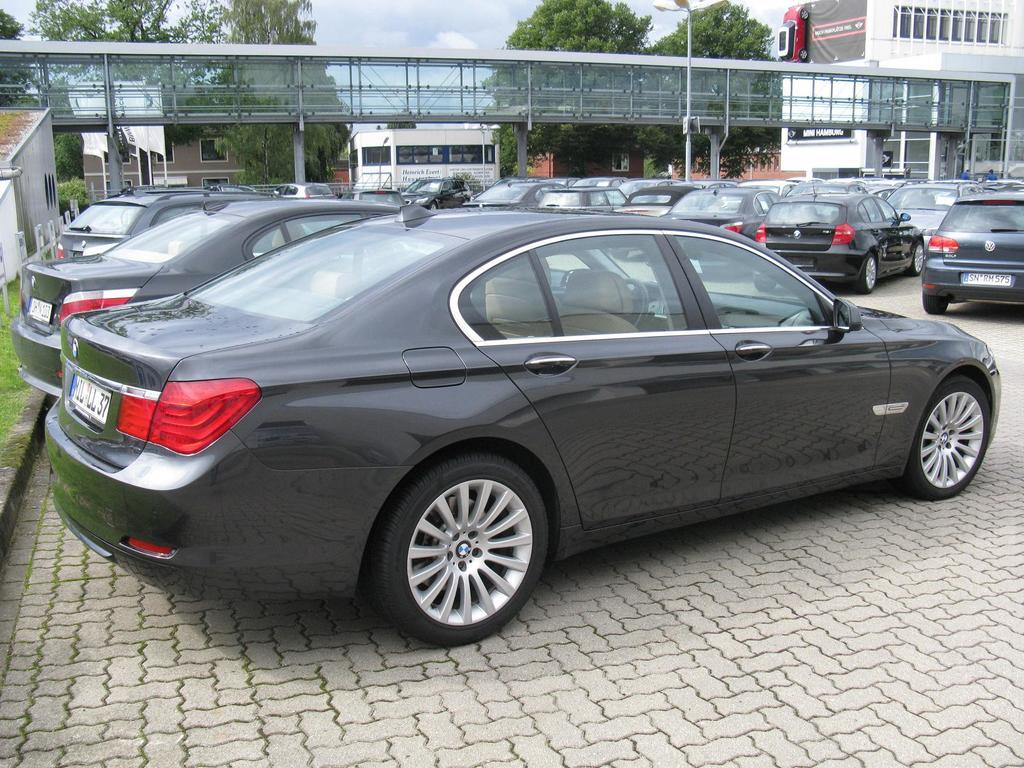What can be seen on the road in the image? There are cars parked on the road in the image. What structure is visible in the image? There is a bridge visible in the image. What type of man-made structures are present in the image? There are buildings in the image. What natural elements can be seen in the image? There are a lot of trees at the back of the image. What type of wall is visible in the image? There is no wall visible in the image. What color is the straw in the image? There is no straw present in the image. 